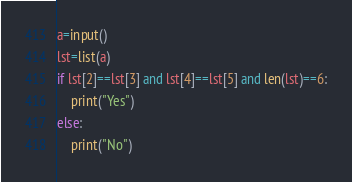Convert code to text. <code><loc_0><loc_0><loc_500><loc_500><_Python_>a=input()
lst=list(a)
if lst[2]==lst[3] and lst[4]==lst[5] and len(lst)==6:
    print("Yes")
else:
    print("No")</code> 